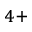<formula> <loc_0><loc_0><loc_500><loc_500>^ { 4 + }</formula> 